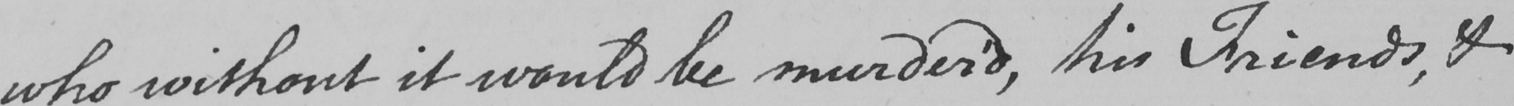Transcribe the text shown in this historical manuscript line. who without it would be murder ' d , his Friends , & 